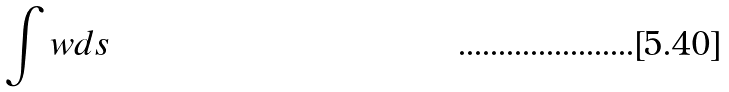Convert formula to latex. <formula><loc_0><loc_0><loc_500><loc_500>\int w d s</formula> 